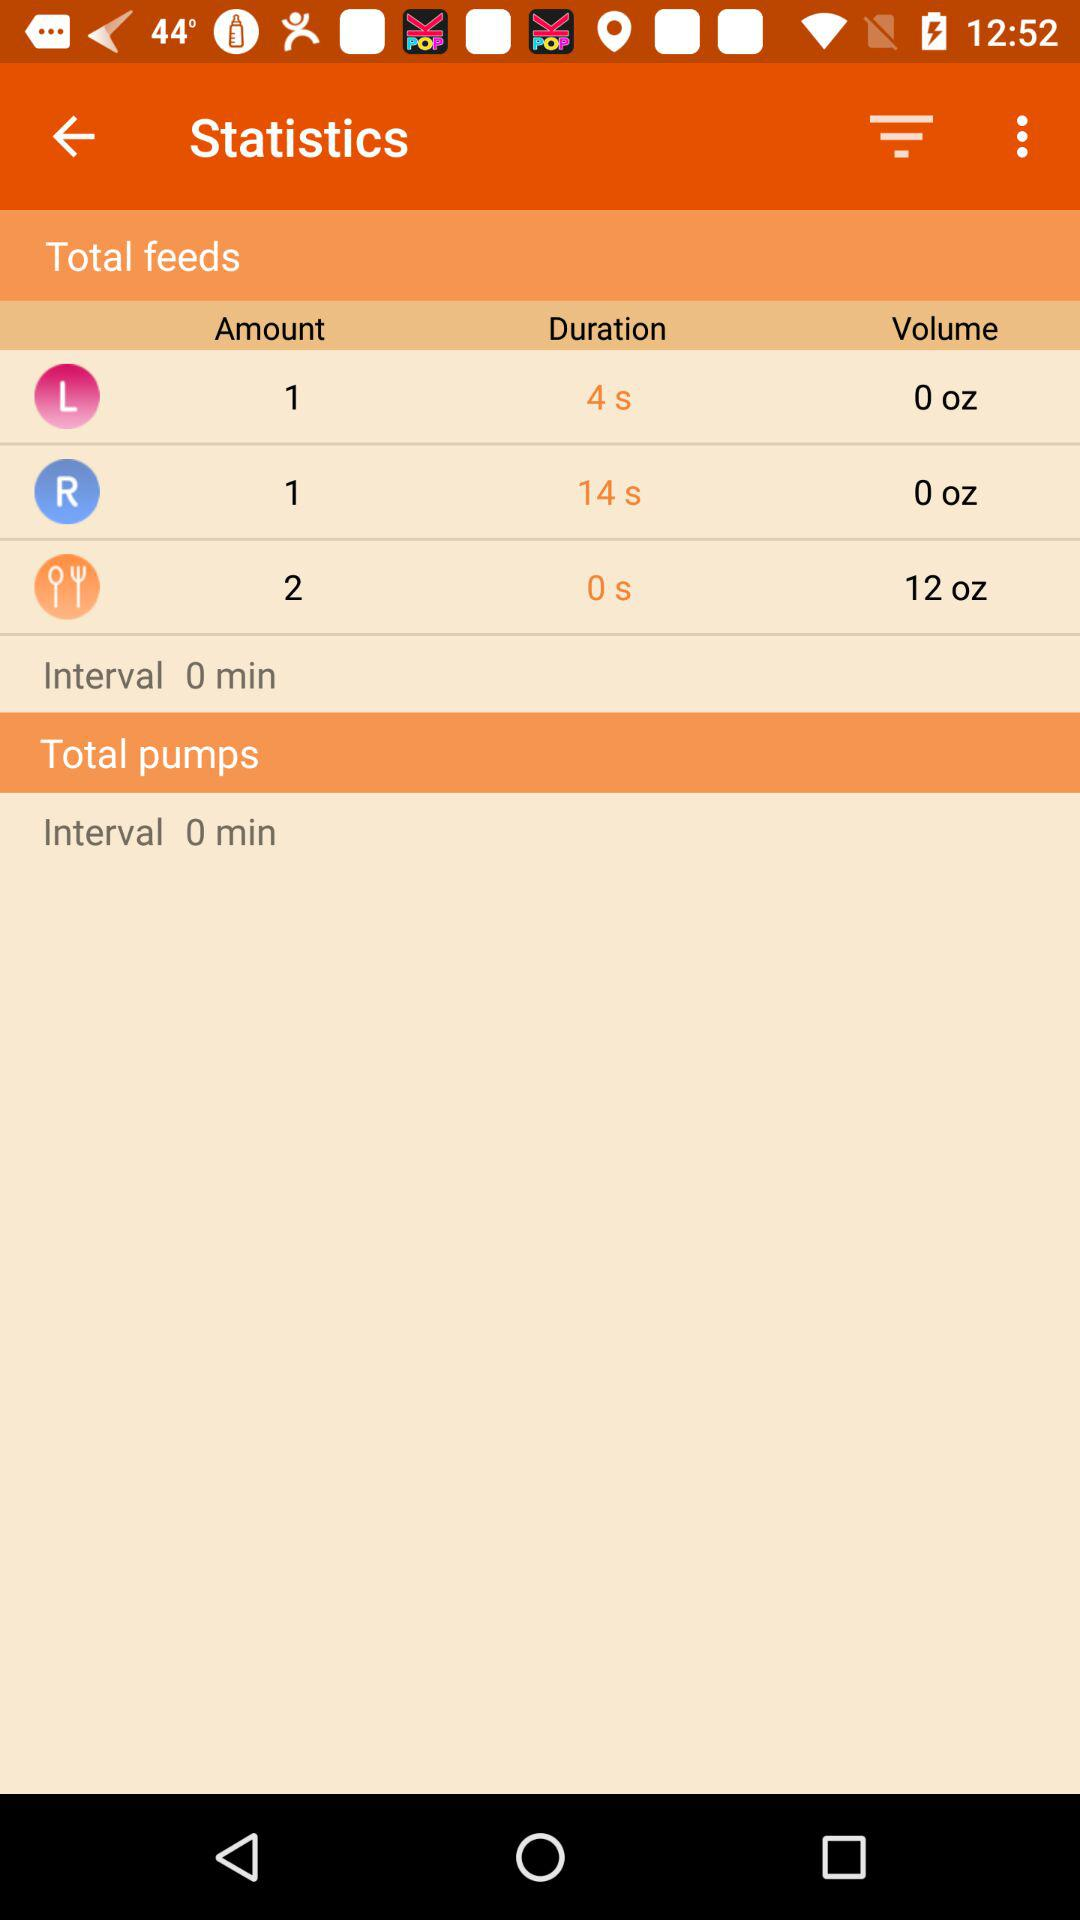What is the interval of total feeds? The interval is 0 minutes. 